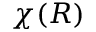<formula> <loc_0><loc_0><loc_500><loc_500>\chi ( R )</formula> 